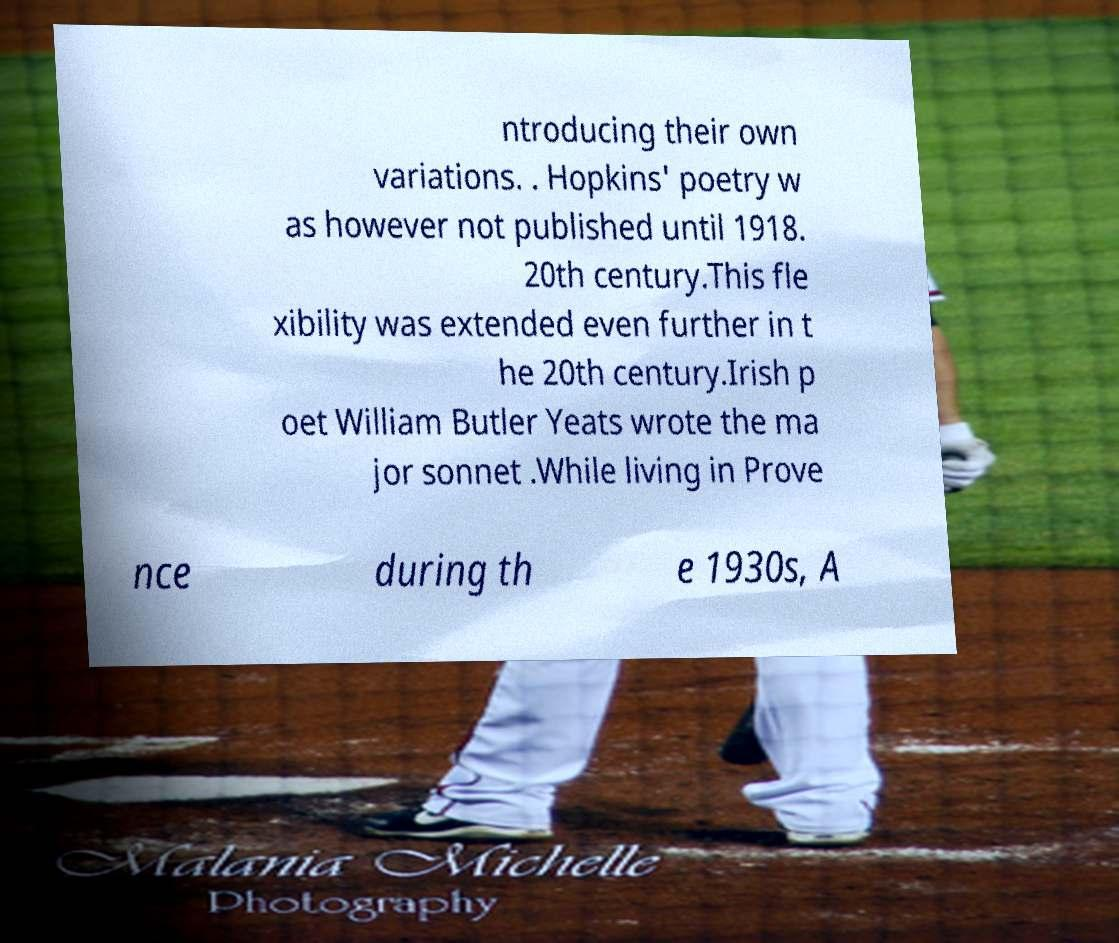Could you assist in decoding the text presented in this image and type it out clearly? ntroducing their own variations. . Hopkins' poetry w as however not published until 1918. 20th century.This fle xibility was extended even further in t he 20th century.Irish p oet William Butler Yeats wrote the ma jor sonnet .While living in Prove nce during th e 1930s, A 